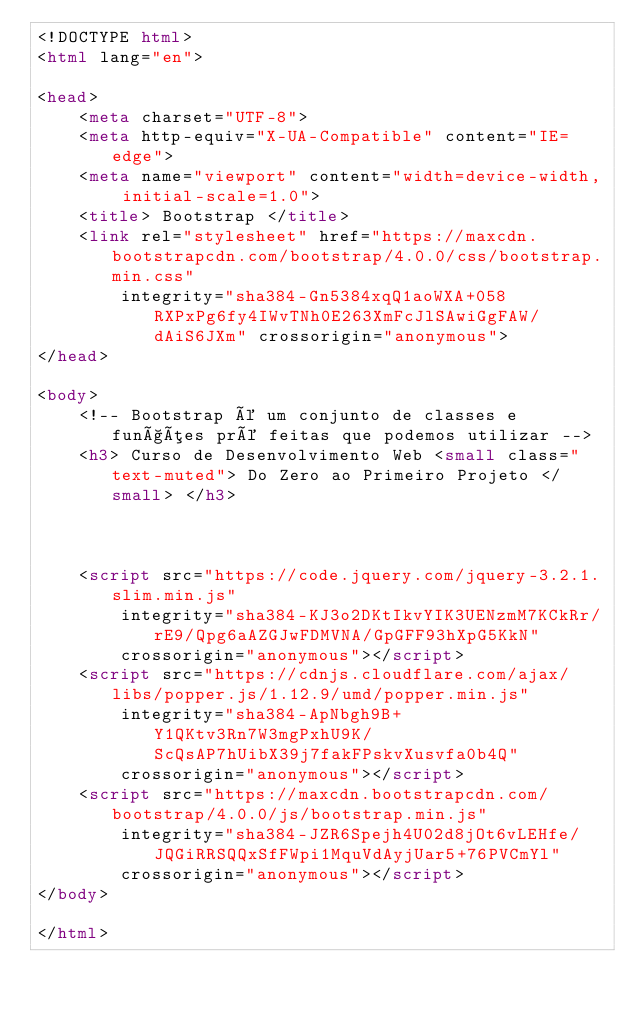Convert code to text. <code><loc_0><loc_0><loc_500><loc_500><_HTML_><!DOCTYPE html>
<html lang="en">

<head>
    <meta charset="UTF-8">
    <meta http-equiv="X-UA-Compatible" content="IE=edge">
    <meta name="viewport" content="width=device-width, initial-scale=1.0">
    <title> Bootstrap </title>
    <link rel="stylesheet" href="https://maxcdn.bootstrapcdn.com/bootstrap/4.0.0/css/bootstrap.min.css"
        integrity="sha384-Gn5384xqQ1aoWXA+058RXPxPg6fy4IWvTNh0E263XmFcJlSAwiGgFAW/dAiS6JXm" crossorigin="anonymous">
</head>

<body>
    <!-- Bootstrap é um conjunto de classes e funções pré feitas que podemos utilizar -->
    <h3> Curso de Desenvolvimento Web <small class="text-muted"> Do Zero ao Primeiro Projeto </small> </h3>



    <script src="https://code.jquery.com/jquery-3.2.1.slim.min.js"
        integrity="sha384-KJ3o2DKtIkvYIK3UENzmM7KCkRr/rE9/Qpg6aAZGJwFDMVNA/GpGFF93hXpG5KkN"
        crossorigin="anonymous"></script>
    <script src="https://cdnjs.cloudflare.com/ajax/libs/popper.js/1.12.9/umd/popper.min.js"
        integrity="sha384-ApNbgh9B+Y1QKtv3Rn7W3mgPxhU9K/ScQsAP7hUibX39j7fakFPskvXusvfa0b4Q"
        crossorigin="anonymous"></script>
    <script src="https://maxcdn.bootstrapcdn.com/bootstrap/4.0.0/js/bootstrap.min.js"
        integrity="sha384-JZR6Spejh4U02d8jOt6vLEHfe/JQGiRRSQQxSfFWpi1MquVdAyjUar5+76PVCmYl"
        crossorigin="anonymous"></script>
</body>

</html></code> 